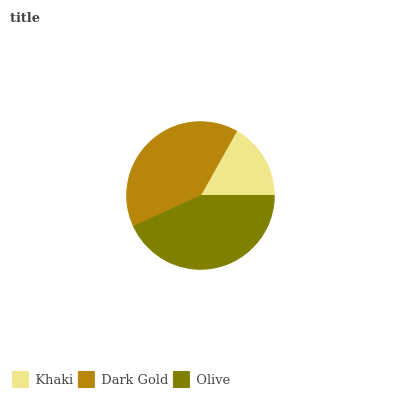Is Khaki the minimum?
Answer yes or no. Yes. Is Olive the maximum?
Answer yes or no. Yes. Is Dark Gold the minimum?
Answer yes or no. No. Is Dark Gold the maximum?
Answer yes or no. No. Is Dark Gold greater than Khaki?
Answer yes or no. Yes. Is Khaki less than Dark Gold?
Answer yes or no. Yes. Is Khaki greater than Dark Gold?
Answer yes or no. No. Is Dark Gold less than Khaki?
Answer yes or no. No. Is Dark Gold the high median?
Answer yes or no. Yes. Is Dark Gold the low median?
Answer yes or no. Yes. Is Khaki the high median?
Answer yes or no. No. Is Olive the low median?
Answer yes or no. No. 